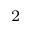<formula> <loc_0><loc_0><loc_500><loc_500>^ { 2 }</formula> 